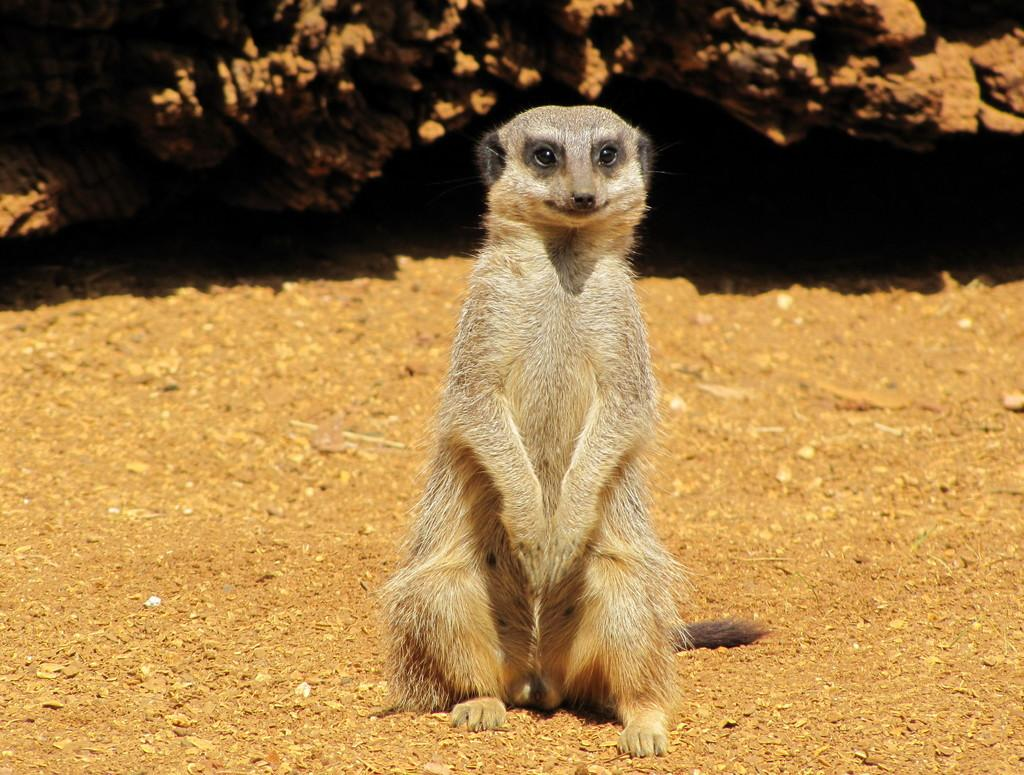What is on the ground in the image? There is an animal on the ground in the image. Can you describe the object in the background of the image? Unfortunately, the provided facts do not give any details about the object in the background. What type of minister is seen taking notes in the afternoon in the image? There is no minister, notebook, or afternoon depicted in the image. The image only features an animal on the ground and an unspecified object in the background. 